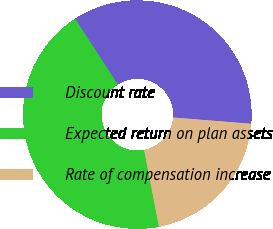Convert chart. <chart><loc_0><loc_0><loc_500><loc_500><pie_chart><fcel>Discount rate<fcel>Expected return on plan assets<fcel>Rate of compensation increase<nl><fcel>35.44%<fcel>43.86%<fcel>20.69%<nl></chart> 